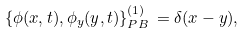<formula> <loc_0><loc_0><loc_500><loc_500>\{ \phi ( x , t ) , \phi _ { y } ( y , t ) \} _ { P B } ^ { ( 1 ) } \, = \delta ( x - y ) ,</formula> 